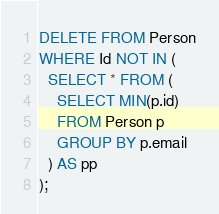Convert code to text. <code><loc_0><loc_0><loc_500><loc_500><_SQL_>DELETE FROM Person
WHERE Id NOT IN (
  SELECT * FROM (
    SELECT MIN(p.id)
    FROM Person p
    GROUP BY p.email
  ) AS pp
);
</code> 